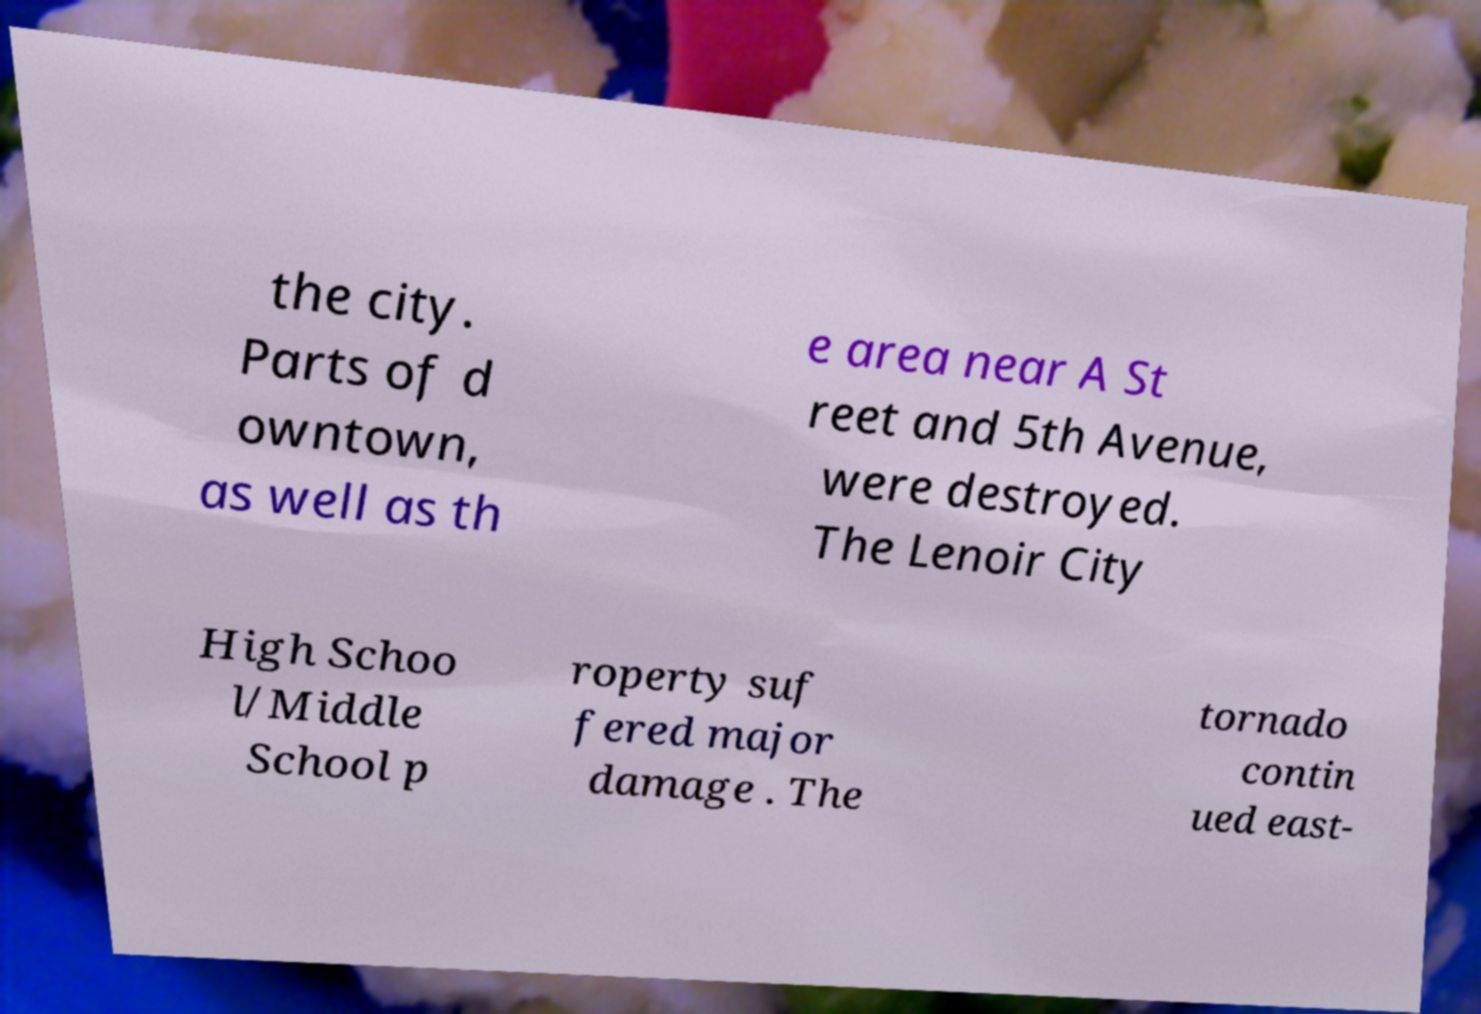What messages or text are displayed in this image? I need them in a readable, typed format. the city. Parts of d owntown, as well as th e area near A St reet and 5th Avenue, were destroyed. The Lenoir City High Schoo l/Middle School p roperty suf fered major damage . The tornado contin ued east- 